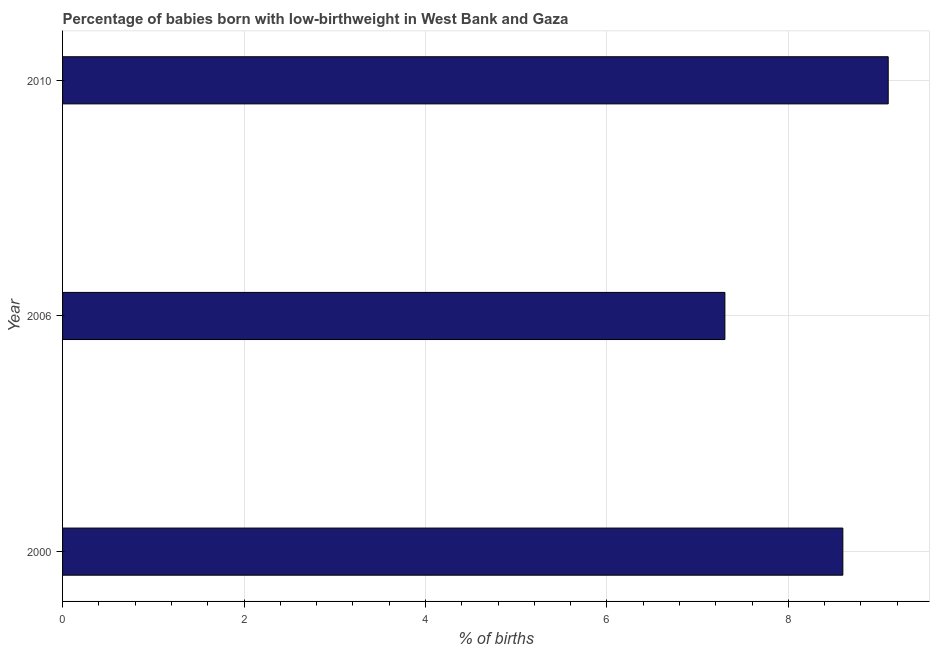Does the graph contain grids?
Ensure brevity in your answer.  Yes. What is the title of the graph?
Your response must be concise. Percentage of babies born with low-birthweight in West Bank and Gaza. What is the label or title of the X-axis?
Keep it short and to the point. % of births. What is the label or title of the Y-axis?
Offer a terse response. Year. What is the percentage of babies who were born with low-birthweight in 2006?
Make the answer very short. 7.3. In which year was the percentage of babies who were born with low-birthweight maximum?
Keep it short and to the point. 2010. In which year was the percentage of babies who were born with low-birthweight minimum?
Your answer should be very brief. 2006. What is the sum of the percentage of babies who were born with low-birthweight?
Your answer should be very brief. 25. What is the average percentage of babies who were born with low-birthweight per year?
Offer a terse response. 8.33. In how many years, is the percentage of babies who were born with low-birthweight greater than 2.4 %?
Provide a succinct answer. 3. Do a majority of the years between 2006 and 2010 (inclusive) have percentage of babies who were born with low-birthweight greater than 5.2 %?
Your answer should be compact. Yes. What is the ratio of the percentage of babies who were born with low-birthweight in 2000 to that in 2010?
Ensure brevity in your answer.  0.94. What is the difference between the highest and the second highest percentage of babies who were born with low-birthweight?
Ensure brevity in your answer.  0.5. Is the sum of the percentage of babies who were born with low-birthweight in 2000 and 2010 greater than the maximum percentage of babies who were born with low-birthweight across all years?
Offer a terse response. Yes. What is the difference between the highest and the lowest percentage of babies who were born with low-birthweight?
Your answer should be compact. 1.8. In how many years, is the percentage of babies who were born with low-birthweight greater than the average percentage of babies who were born with low-birthweight taken over all years?
Keep it short and to the point. 2. How many bars are there?
Give a very brief answer. 3. Are all the bars in the graph horizontal?
Provide a succinct answer. Yes. How many years are there in the graph?
Ensure brevity in your answer.  3. What is the % of births in 2000?
Provide a succinct answer. 8.6. What is the % of births of 2010?
Offer a very short reply. 9.1. What is the ratio of the % of births in 2000 to that in 2006?
Make the answer very short. 1.18. What is the ratio of the % of births in 2000 to that in 2010?
Ensure brevity in your answer.  0.94. What is the ratio of the % of births in 2006 to that in 2010?
Your answer should be compact. 0.8. 